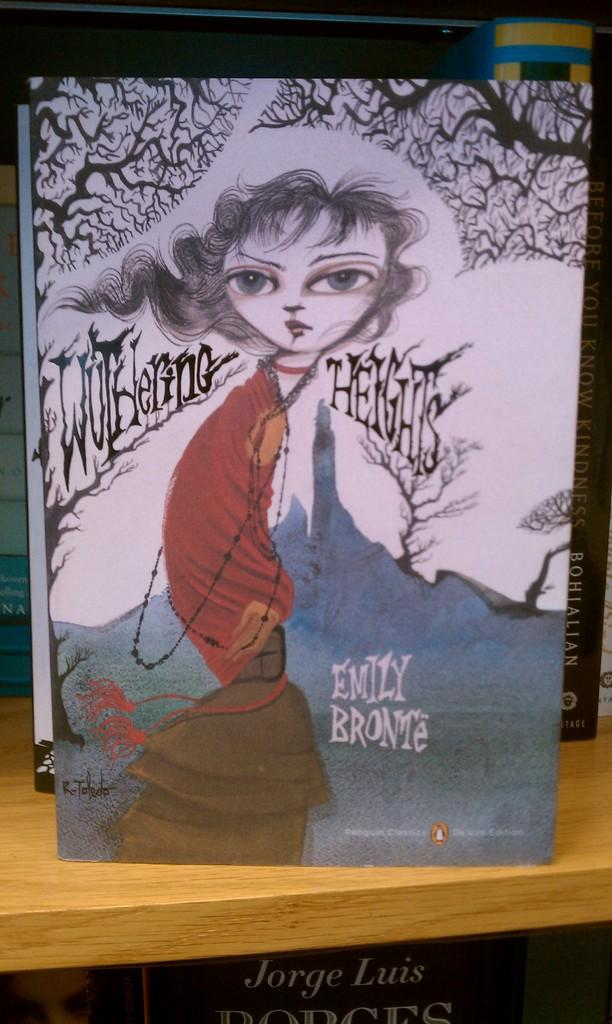<image>
Create a compact narrative representing the image presented. A modern looking book cover of Wuthering Heights. 